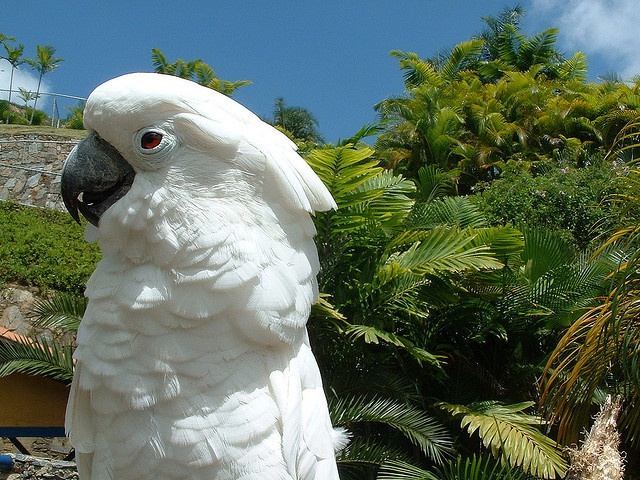Describe the objects in this image and their specific colors. I can see a bird in teal, white, darkgray, and gray tones in this image. 